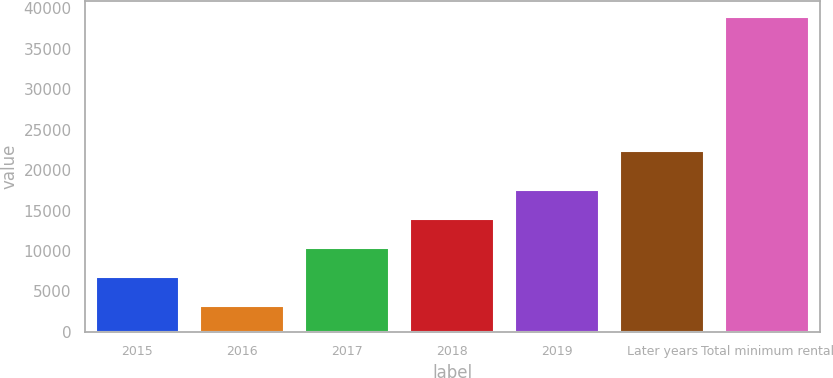Convert chart. <chart><loc_0><loc_0><loc_500><loc_500><bar_chart><fcel>2015<fcel>2016<fcel>2017<fcel>2018<fcel>2019<fcel>Later years<fcel>Total minimum rental<nl><fcel>6825.9<fcel>3261<fcel>10390.8<fcel>13955.7<fcel>17520.6<fcel>22356<fcel>38910<nl></chart> 